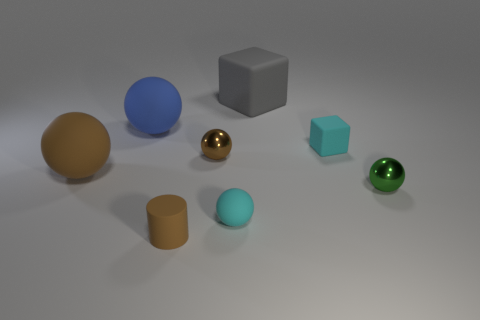Add 2 small purple balls. How many objects exist? 10 Subtract all small cyan spheres. How many spheres are left? 4 Subtract all cyan cubes. How many cubes are left? 1 Subtract all cyan cylinders. How many brown balls are left? 2 Subtract 1 cylinders. How many cylinders are left? 0 Subtract all blocks. How many objects are left? 6 Add 6 small green metallic spheres. How many small green metallic spheres are left? 7 Add 1 big blue matte things. How many big blue matte things exist? 2 Subtract 0 green cubes. How many objects are left? 8 Subtract all blue balls. Subtract all green cubes. How many balls are left? 4 